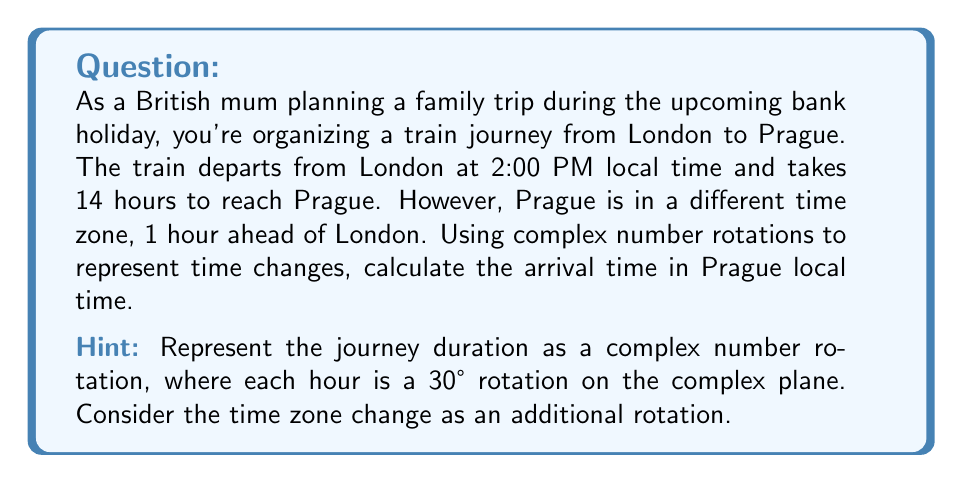Teach me how to tackle this problem. Let's approach this problem step-by-step using complex number rotations:

1) First, we need to represent time as complex numbers on a 12-hour clock face. Each hour corresponds to a 30° rotation (360° ÷ 12 = 30°).

2) The starting time, 2:00 PM, can be represented as the complex number:
   $$z_1 = e^{i\frac{\pi}{3}}$$
   (since 2 hours past noon is a 60° or $\frac{\pi}{3}$ radian rotation)

3) The 14-hour journey can be represented as a rotation of:
   $$14 \cdot 30° = 420° = \frac{7\pi}{3}$$ radians

4) This rotation is represented by the complex number:
   $$z_2 = e^{i\frac{7\pi}{3}}$$

5) The time zone change of +1 hour is an additional 30° or $\frac{\pi}{6}$ radian rotation:
   $$z_3 = e^{i\frac{\pi}{6}}$$

6) The final time is the product of these rotations:
   $$z_{final} = z_1 \cdot z_2 \cdot z_3 = e^{i\frac{\pi}{3}} \cdot e^{i\frac{7\pi}{3}} \cdot e^{i\frac{\pi}{6}}$$

7) Simplifying:
   $$z_{final} = e^{i(\frac{\pi}{3} + \frac{7\pi}{3} + \frac{\pi}{6})} = e^{i\frac{11\pi}{6}}$$

8) $\frac{11\pi}{6}$ radians is equivalent to 330°, which on a 12-hour clock face represents 5:00.

9) Since we started at 2:00 PM, 5:00 on the clock face represents 5:00 AM the next day.

Therefore, the train arrives in Prague at 5:00 AM local time the next day.
Answer: 5:00 AM (local time in Prague) 